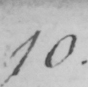Can you tell me what this handwritten text says? 10 . 